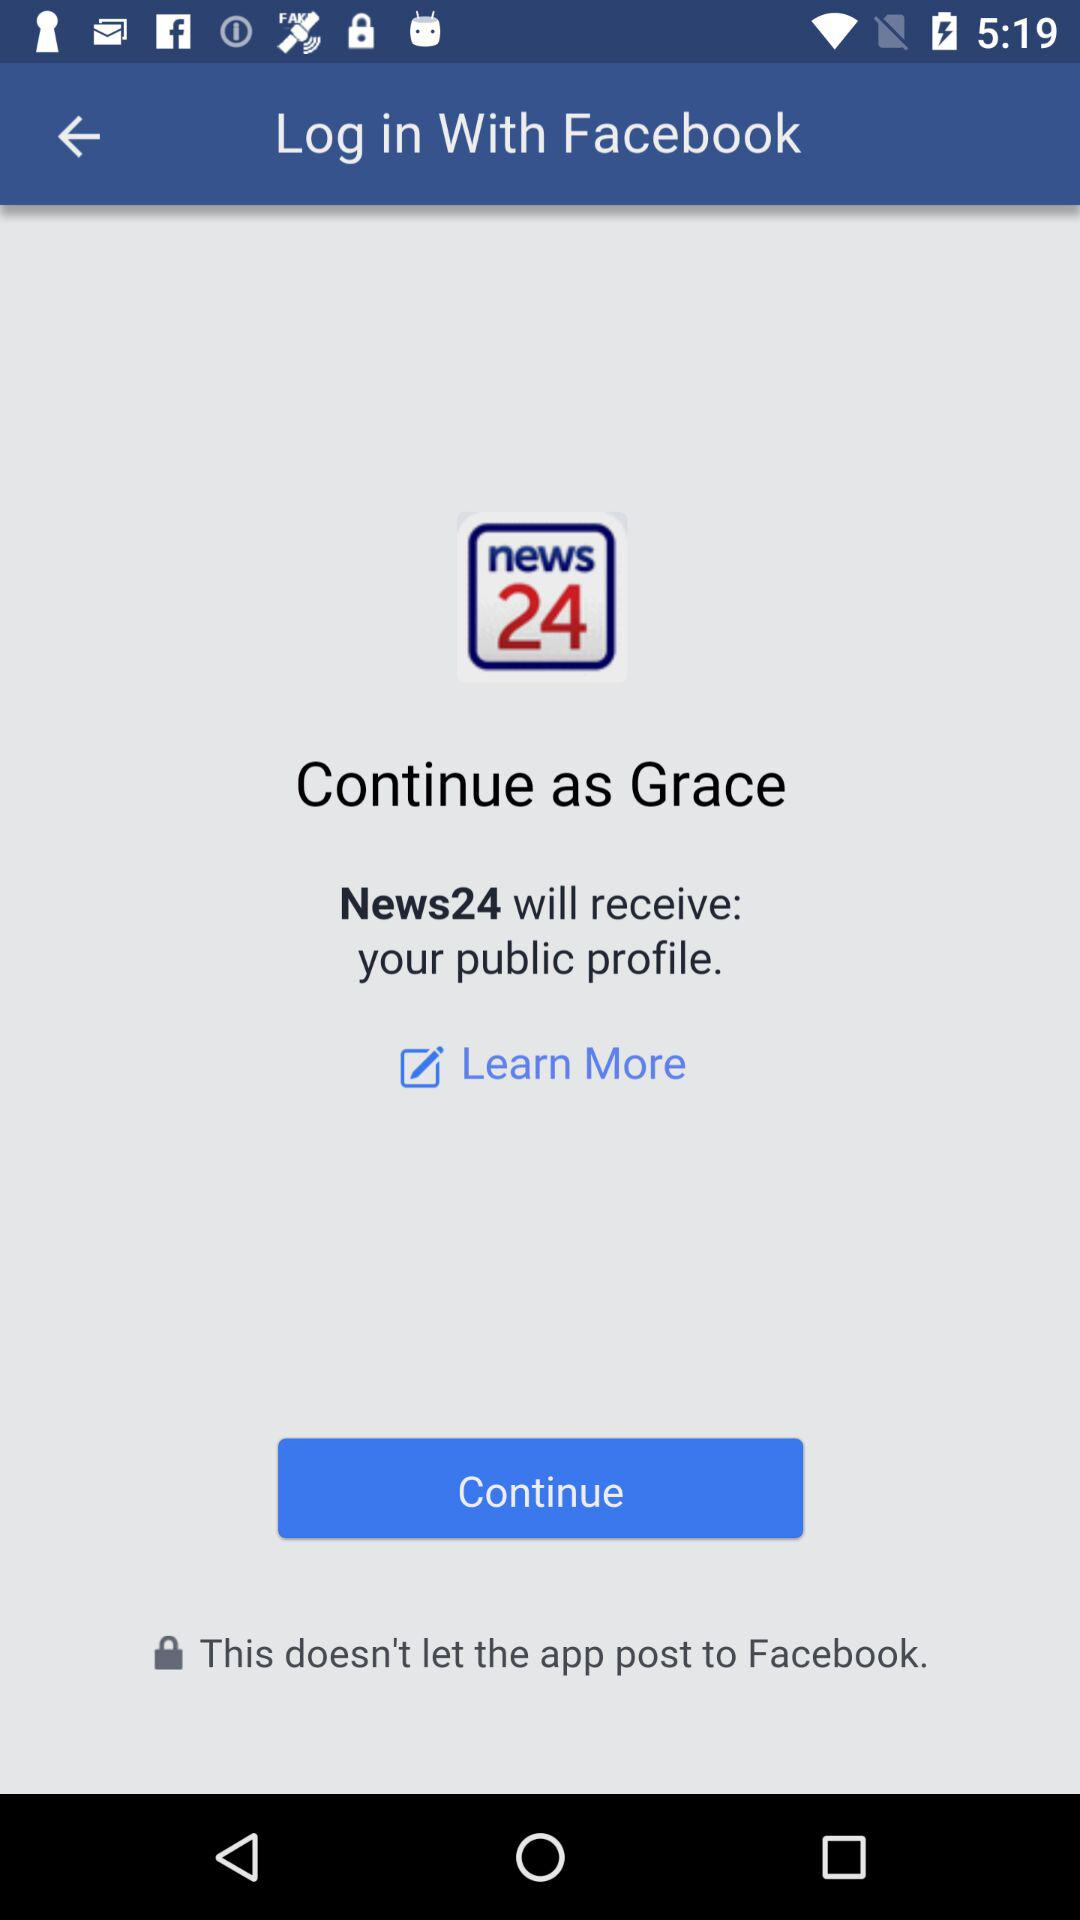What application is asking for permission? The application asking for permission is "News24". 